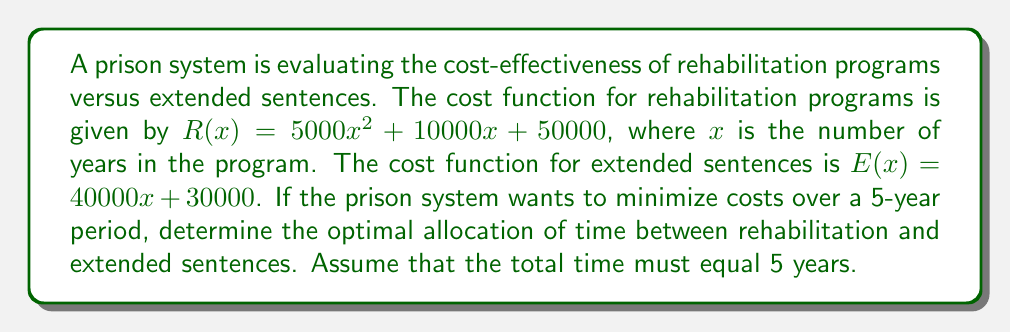Solve this math problem. To solve this problem, we need to minimize the total cost function over a 5-year period. Let's approach this step-by-step:

1) Let $y$ be the number of years in rehabilitation. Then, $5-y$ will be the number of years in extended sentences.

2) The total cost function $T(y)$ is the sum of both programs:
   $T(y) = R(y) + E(5-y)$

3) Substituting the given functions:
   $T(y) = (5000y^2 + 10000y + 50000) + (40000(5-y) + 30000)$

4) Simplify:
   $T(y) = 5000y^2 + 10000y + 50000 + 200000 - 40000y + 30000$
   $T(y) = 5000y^2 - 30000y + 280000$

5) To find the minimum, we differentiate $T(y)$ and set it to zero:
   $T'(y) = 10000y - 30000 = 0$

6) Solve for $y$:
   $10000y = 30000$
   $y = 3$

7) To confirm this is a minimum, check the second derivative:
   $T''(y) = 10000 > 0$, confirming a minimum.

8) Therefore, the optimal allocation is 3 years in rehabilitation and 2 years in extended sentences.

9) To verify cost-effectiveness, calculate the total cost:
   $T(3) = 5000(3)^2 - 30000(3) + 280000 = 235000$

   Compare this to all rehabilitation or all extended sentences:
   All rehabilitation: $R(5) = 5000(5)^2 + 10000(5) + 50000 = 225000$
   All extended sentences: $E(5) = 40000(5) + 30000 = 230000$

   The optimal mix is slightly more expensive, but may offer better outcomes in terms of reduced recidivism.
Answer: The optimal allocation is 3 years in rehabilitation programs and 2 years in extended sentences, with a total cost of $235,000. 